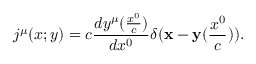<formula> <loc_0><loc_0><loc_500><loc_500>j ^ { \mu } ( x ; y ) = c \frac { d y ^ { \mu } ( \frac { x ^ { 0 } } { c } ) } { d x ^ { 0 } } \delta ( { x } - { y } ( \frac { x ^ { 0 } } { c } ) ) .</formula> 